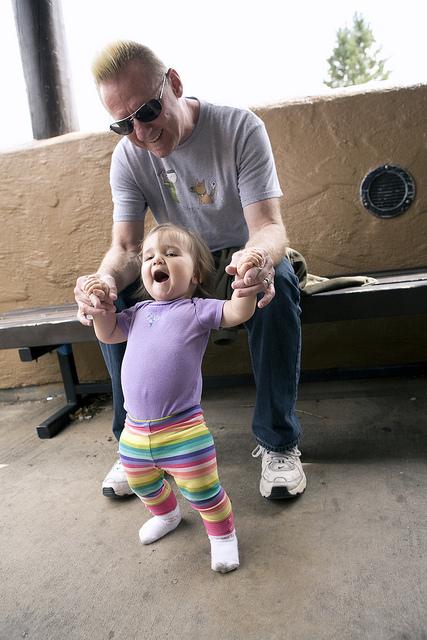How many shoes are seen?
Be succinct. 2. What kind of wall is behind the people?
Answer briefly. Stone. Is this man helping the child walk?
Keep it brief. Yes. 